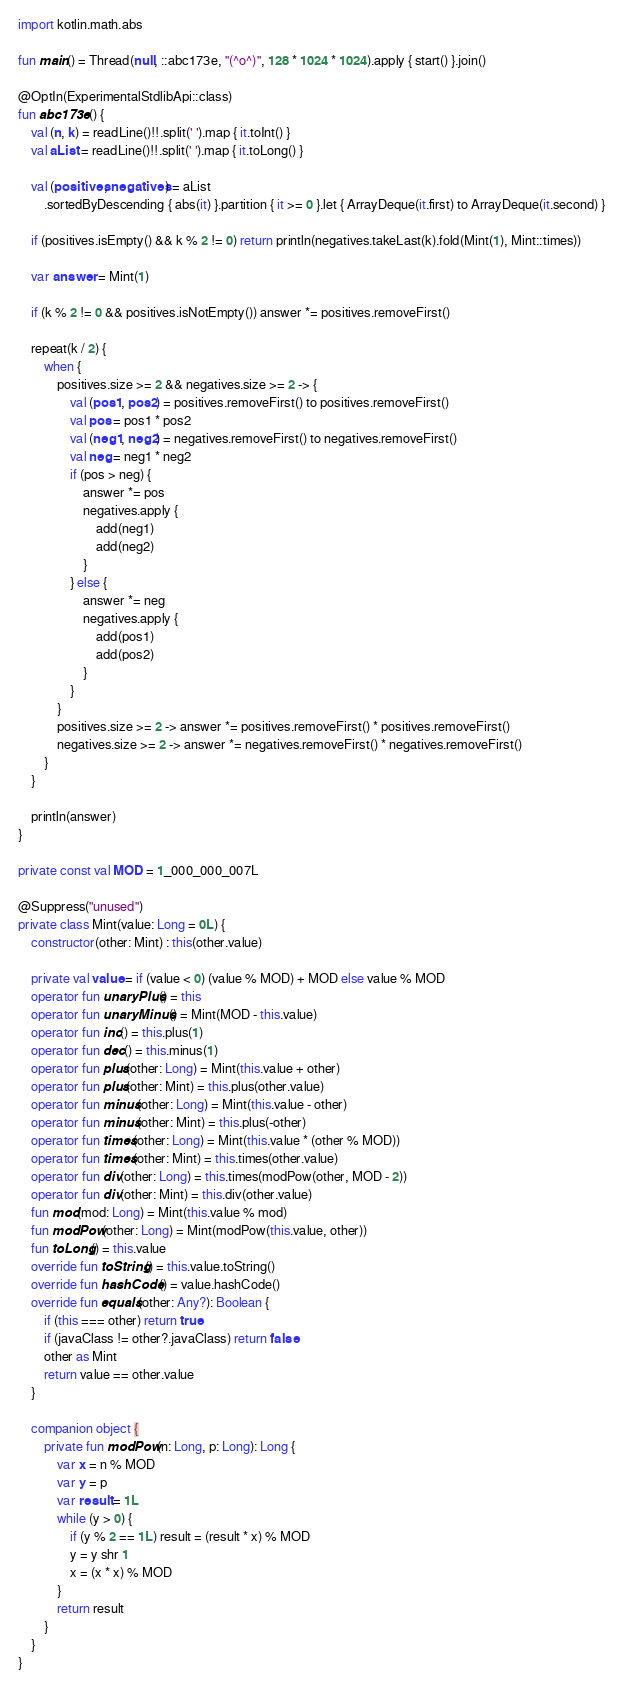Convert code to text. <code><loc_0><loc_0><loc_500><loc_500><_Kotlin_>import kotlin.math.abs

fun main() = Thread(null, ::abc173e, "(^o^)", 128 * 1024 * 1024).apply { start() }.join()

@OptIn(ExperimentalStdlibApi::class)
fun abc173e() {
    val (n, k) = readLine()!!.split(' ').map { it.toInt() }
    val aList = readLine()!!.split(' ').map { it.toLong() }

    val (positives, negatives) = aList
        .sortedByDescending { abs(it) }.partition { it >= 0 }.let { ArrayDeque(it.first) to ArrayDeque(it.second) }

    if (positives.isEmpty() && k % 2 != 0) return println(negatives.takeLast(k).fold(Mint(1), Mint::times))

    var answer = Mint(1)

    if (k % 2 != 0 && positives.isNotEmpty()) answer *= positives.removeFirst()

    repeat(k / 2) {
        when {
            positives.size >= 2 && negatives.size >= 2 -> {
                val (pos1, pos2) = positives.removeFirst() to positives.removeFirst()
                val pos = pos1 * pos2
                val (neg1, neg2) = negatives.removeFirst() to negatives.removeFirst()
                val neg = neg1 * neg2
                if (pos > neg) {
                    answer *= pos
                    negatives.apply {
                        add(neg1)
                        add(neg2)
                    }
                } else {
                    answer *= neg
                    negatives.apply {
                        add(pos1)
                        add(pos2)
                    }
                }
            }
            positives.size >= 2 -> answer *= positives.removeFirst() * positives.removeFirst()
            negatives.size >= 2 -> answer *= negatives.removeFirst() * negatives.removeFirst()
        }
    }

    println(answer)
}

private const val MOD = 1_000_000_007L

@Suppress("unused")
private class Mint(value: Long = 0L) {
    constructor(other: Mint) : this(other.value)

    private val value = if (value < 0) (value % MOD) + MOD else value % MOD
    operator fun unaryPlus() = this
    operator fun unaryMinus() = Mint(MOD - this.value)
    operator fun inc() = this.plus(1)
    operator fun dec() = this.minus(1)
    operator fun plus(other: Long) = Mint(this.value + other)
    operator fun plus(other: Mint) = this.plus(other.value)
    operator fun minus(other: Long) = Mint(this.value - other)
    operator fun minus(other: Mint) = this.plus(-other)
    operator fun times(other: Long) = Mint(this.value * (other % MOD))
    operator fun times(other: Mint) = this.times(other.value)
    operator fun div(other: Long) = this.times(modPow(other, MOD - 2))
    operator fun div(other: Mint) = this.div(other.value)
    fun mod(mod: Long) = Mint(this.value % mod)
    fun modPow(other: Long) = Mint(modPow(this.value, other))
    fun toLong() = this.value
    override fun toString() = this.value.toString()
    override fun hashCode() = value.hashCode()
    override fun equals(other: Any?): Boolean {
        if (this === other) return true
        if (javaClass != other?.javaClass) return false
        other as Mint
        return value == other.value
    }

    companion object {
        private fun modPow(n: Long, p: Long): Long {
            var x = n % MOD
            var y = p
            var result = 1L
            while (y > 0) {
                if (y % 2 == 1L) result = (result * x) % MOD
                y = y shr 1
                x = (x * x) % MOD
            }
            return result
        }
    }
}
</code> 